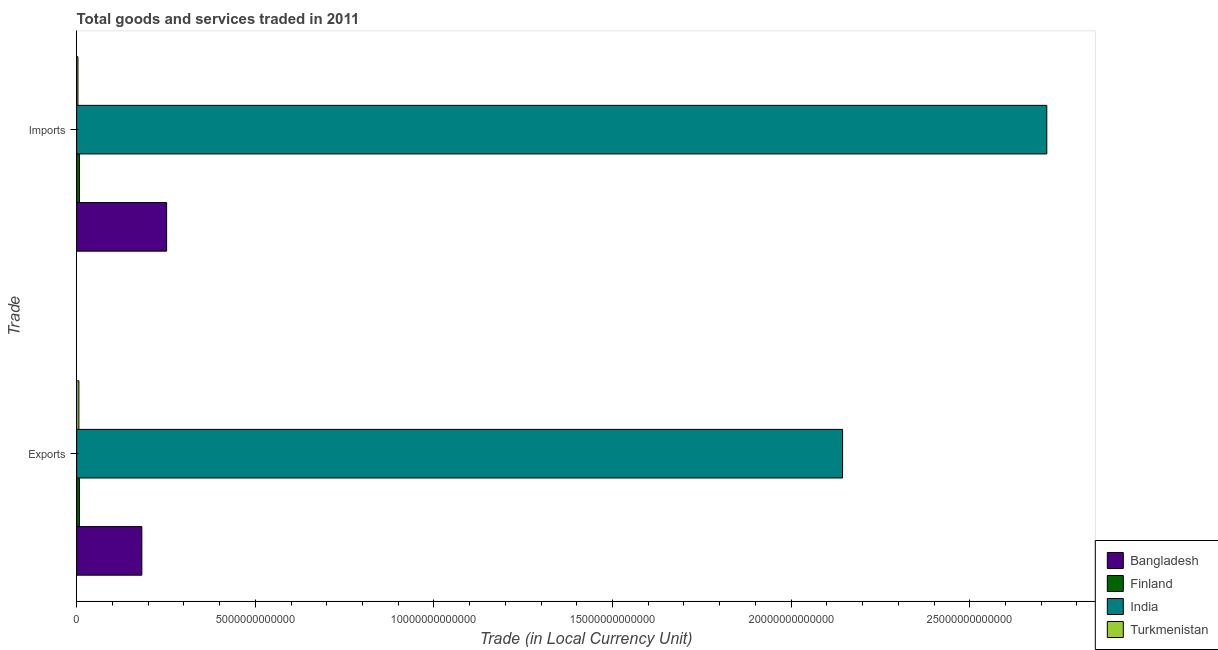How many groups of bars are there?
Ensure brevity in your answer.  2. What is the label of the 2nd group of bars from the top?
Make the answer very short. Exports. What is the imports of goods and services in India?
Keep it short and to the point. 2.72e+13. Across all countries, what is the maximum export of goods and services?
Provide a succinct answer. 2.14e+13. Across all countries, what is the minimum imports of goods and services?
Ensure brevity in your answer.  3.63e+1. In which country was the export of goods and services maximum?
Your answer should be compact. India. In which country was the imports of goods and services minimum?
Provide a short and direct response. Turkmenistan. What is the total imports of goods and services in the graph?
Give a very brief answer. 2.98e+13. What is the difference between the export of goods and services in Bangladesh and that in India?
Offer a terse response. -1.96e+13. What is the difference between the export of goods and services in Turkmenistan and the imports of goods and services in Finland?
Make the answer very short. -1.65e+1. What is the average export of goods and services per country?
Your answer should be compact. 5.85e+12. What is the difference between the export of goods and services and imports of goods and services in India?
Your answer should be compact. -5.72e+12. In how many countries, is the export of goods and services greater than 1000000000000 LCU?
Your response must be concise. 2. What is the ratio of the export of goods and services in India to that in Turkmenistan?
Make the answer very short. 344.5. Is the imports of goods and services in India less than that in Turkmenistan?
Make the answer very short. No. Are all the bars in the graph horizontal?
Keep it short and to the point. Yes. What is the difference between two consecutive major ticks on the X-axis?
Provide a short and direct response. 5.00e+12. Where does the legend appear in the graph?
Provide a short and direct response. Bottom right. How many legend labels are there?
Keep it short and to the point. 4. What is the title of the graph?
Your response must be concise. Total goods and services traded in 2011. What is the label or title of the X-axis?
Ensure brevity in your answer.  Trade (in Local Currency Unit). What is the label or title of the Y-axis?
Provide a short and direct response. Trade. What is the Trade (in Local Currency Unit) in Bangladesh in Exports?
Make the answer very short. 1.82e+12. What is the Trade (in Local Currency Unit) of Finland in Exports?
Provide a succinct answer. 7.71e+1. What is the Trade (in Local Currency Unit) in India in Exports?
Your answer should be compact. 2.14e+13. What is the Trade (in Local Currency Unit) of Turkmenistan in Exports?
Offer a very short reply. 6.22e+1. What is the Trade (in Local Currency Unit) in Bangladesh in Imports?
Provide a succinct answer. 2.52e+12. What is the Trade (in Local Currency Unit) in Finland in Imports?
Your response must be concise. 7.88e+1. What is the Trade (in Local Currency Unit) of India in Imports?
Keep it short and to the point. 2.72e+13. What is the Trade (in Local Currency Unit) of Turkmenistan in Imports?
Your answer should be very brief. 3.63e+1. Across all Trade, what is the maximum Trade (in Local Currency Unit) in Bangladesh?
Make the answer very short. 2.52e+12. Across all Trade, what is the maximum Trade (in Local Currency Unit) of Finland?
Ensure brevity in your answer.  7.88e+1. Across all Trade, what is the maximum Trade (in Local Currency Unit) in India?
Your response must be concise. 2.72e+13. Across all Trade, what is the maximum Trade (in Local Currency Unit) in Turkmenistan?
Give a very brief answer. 6.22e+1. Across all Trade, what is the minimum Trade (in Local Currency Unit) in Bangladesh?
Ensure brevity in your answer.  1.82e+12. Across all Trade, what is the minimum Trade (in Local Currency Unit) of Finland?
Make the answer very short. 7.71e+1. Across all Trade, what is the minimum Trade (in Local Currency Unit) of India?
Offer a terse response. 2.14e+13. Across all Trade, what is the minimum Trade (in Local Currency Unit) of Turkmenistan?
Provide a short and direct response. 3.63e+1. What is the total Trade (in Local Currency Unit) in Bangladesh in the graph?
Provide a short and direct response. 4.34e+12. What is the total Trade (in Local Currency Unit) in Finland in the graph?
Your response must be concise. 1.56e+11. What is the total Trade (in Local Currency Unit) in India in the graph?
Keep it short and to the point. 4.86e+13. What is the total Trade (in Local Currency Unit) of Turkmenistan in the graph?
Give a very brief answer. 9.85e+1. What is the difference between the Trade (in Local Currency Unit) of Bangladesh in Exports and that in Imports?
Keep it short and to the point. -6.94e+11. What is the difference between the Trade (in Local Currency Unit) of Finland in Exports and that in Imports?
Your answer should be compact. -1.68e+09. What is the difference between the Trade (in Local Currency Unit) of India in Exports and that in Imports?
Provide a short and direct response. -5.72e+12. What is the difference between the Trade (in Local Currency Unit) of Turkmenistan in Exports and that in Imports?
Offer a terse response. 2.60e+1. What is the difference between the Trade (in Local Currency Unit) of Bangladesh in Exports and the Trade (in Local Currency Unit) of Finland in Imports?
Provide a succinct answer. 1.75e+12. What is the difference between the Trade (in Local Currency Unit) of Bangladesh in Exports and the Trade (in Local Currency Unit) of India in Imports?
Keep it short and to the point. -2.53e+13. What is the difference between the Trade (in Local Currency Unit) in Bangladesh in Exports and the Trade (in Local Currency Unit) in Turkmenistan in Imports?
Your answer should be compact. 1.79e+12. What is the difference between the Trade (in Local Currency Unit) of Finland in Exports and the Trade (in Local Currency Unit) of India in Imports?
Offer a very short reply. -2.71e+13. What is the difference between the Trade (in Local Currency Unit) of Finland in Exports and the Trade (in Local Currency Unit) of Turkmenistan in Imports?
Provide a succinct answer. 4.08e+1. What is the difference between the Trade (in Local Currency Unit) of India in Exports and the Trade (in Local Currency Unit) of Turkmenistan in Imports?
Offer a very short reply. 2.14e+13. What is the average Trade (in Local Currency Unit) in Bangladesh per Trade?
Your answer should be very brief. 2.17e+12. What is the average Trade (in Local Currency Unit) of Finland per Trade?
Offer a terse response. 7.79e+1. What is the average Trade (in Local Currency Unit) of India per Trade?
Ensure brevity in your answer.  2.43e+13. What is the average Trade (in Local Currency Unit) of Turkmenistan per Trade?
Give a very brief answer. 4.93e+1. What is the difference between the Trade (in Local Currency Unit) of Bangladesh and Trade (in Local Currency Unit) of Finland in Exports?
Give a very brief answer. 1.75e+12. What is the difference between the Trade (in Local Currency Unit) of Bangladesh and Trade (in Local Currency Unit) of India in Exports?
Your answer should be very brief. -1.96e+13. What is the difference between the Trade (in Local Currency Unit) of Bangladesh and Trade (in Local Currency Unit) of Turkmenistan in Exports?
Your answer should be very brief. 1.76e+12. What is the difference between the Trade (in Local Currency Unit) in Finland and Trade (in Local Currency Unit) in India in Exports?
Provide a succinct answer. -2.14e+13. What is the difference between the Trade (in Local Currency Unit) of Finland and Trade (in Local Currency Unit) of Turkmenistan in Exports?
Give a very brief answer. 1.49e+1. What is the difference between the Trade (in Local Currency Unit) of India and Trade (in Local Currency Unit) of Turkmenistan in Exports?
Your answer should be compact. 2.14e+13. What is the difference between the Trade (in Local Currency Unit) of Bangladesh and Trade (in Local Currency Unit) of Finland in Imports?
Your answer should be compact. 2.44e+12. What is the difference between the Trade (in Local Currency Unit) in Bangladesh and Trade (in Local Currency Unit) in India in Imports?
Ensure brevity in your answer.  -2.46e+13. What is the difference between the Trade (in Local Currency Unit) of Bangladesh and Trade (in Local Currency Unit) of Turkmenistan in Imports?
Provide a succinct answer. 2.48e+12. What is the difference between the Trade (in Local Currency Unit) of Finland and Trade (in Local Currency Unit) of India in Imports?
Your response must be concise. -2.71e+13. What is the difference between the Trade (in Local Currency Unit) of Finland and Trade (in Local Currency Unit) of Turkmenistan in Imports?
Your answer should be compact. 4.25e+1. What is the difference between the Trade (in Local Currency Unit) in India and Trade (in Local Currency Unit) in Turkmenistan in Imports?
Your answer should be very brief. 2.71e+13. What is the ratio of the Trade (in Local Currency Unit) in Bangladesh in Exports to that in Imports?
Make the answer very short. 0.72. What is the ratio of the Trade (in Local Currency Unit) of Finland in Exports to that in Imports?
Offer a very short reply. 0.98. What is the ratio of the Trade (in Local Currency Unit) of India in Exports to that in Imports?
Make the answer very short. 0.79. What is the ratio of the Trade (in Local Currency Unit) of Turkmenistan in Exports to that in Imports?
Offer a very short reply. 1.72. What is the difference between the highest and the second highest Trade (in Local Currency Unit) of Bangladesh?
Give a very brief answer. 6.94e+11. What is the difference between the highest and the second highest Trade (in Local Currency Unit) in Finland?
Provide a succinct answer. 1.68e+09. What is the difference between the highest and the second highest Trade (in Local Currency Unit) in India?
Provide a short and direct response. 5.72e+12. What is the difference between the highest and the second highest Trade (in Local Currency Unit) in Turkmenistan?
Keep it short and to the point. 2.60e+1. What is the difference between the highest and the lowest Trade (in Local Currency Unit) in Bangladesh?
Provide a short and direct response. 6.94e+11. What is the difference between the highest and the lowest Trade (in Local Currency Unit) of Finland?
Provide a succinct answer. 1.68e+09. What is the difference between the highest and the lowest Trade (in Local Currency Unit) of India?
Provide a short and direct response. 5.72e+12. What is the difference between the highest and the lowest Trade (in Local Currency Unit) of Turkmenistan?
Your answer should be very brief. 2.60e+1. 